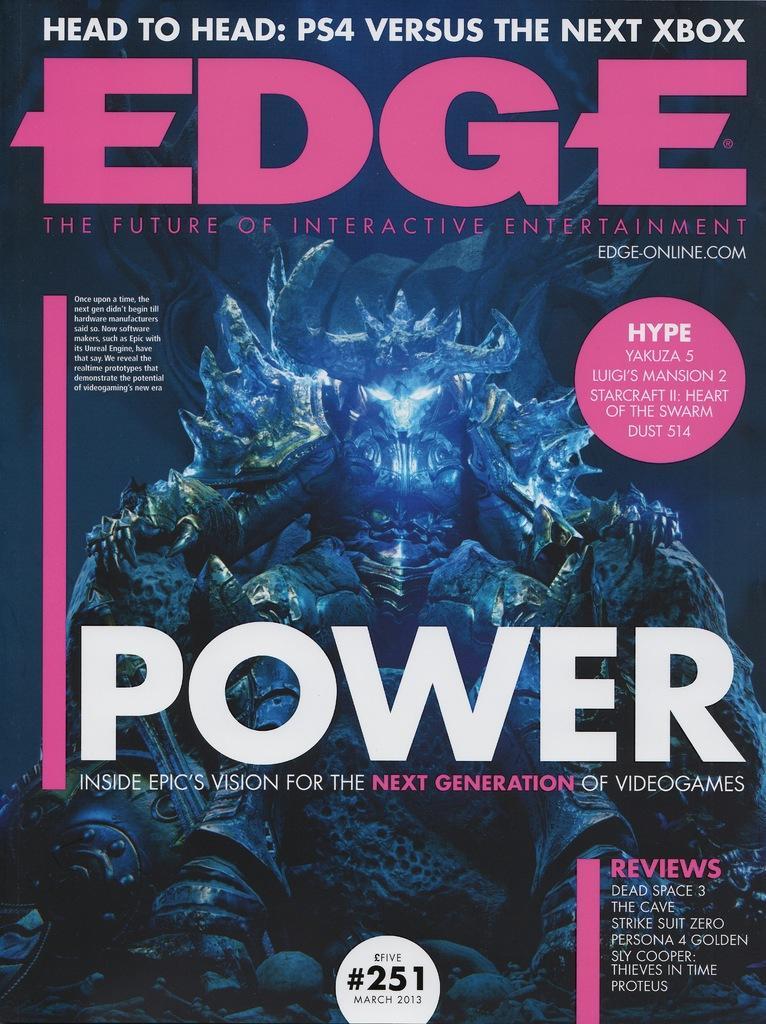In one or two sentences, can you explain what this image depicts? Here we can see a poster. On this poster we can see an animated image. 